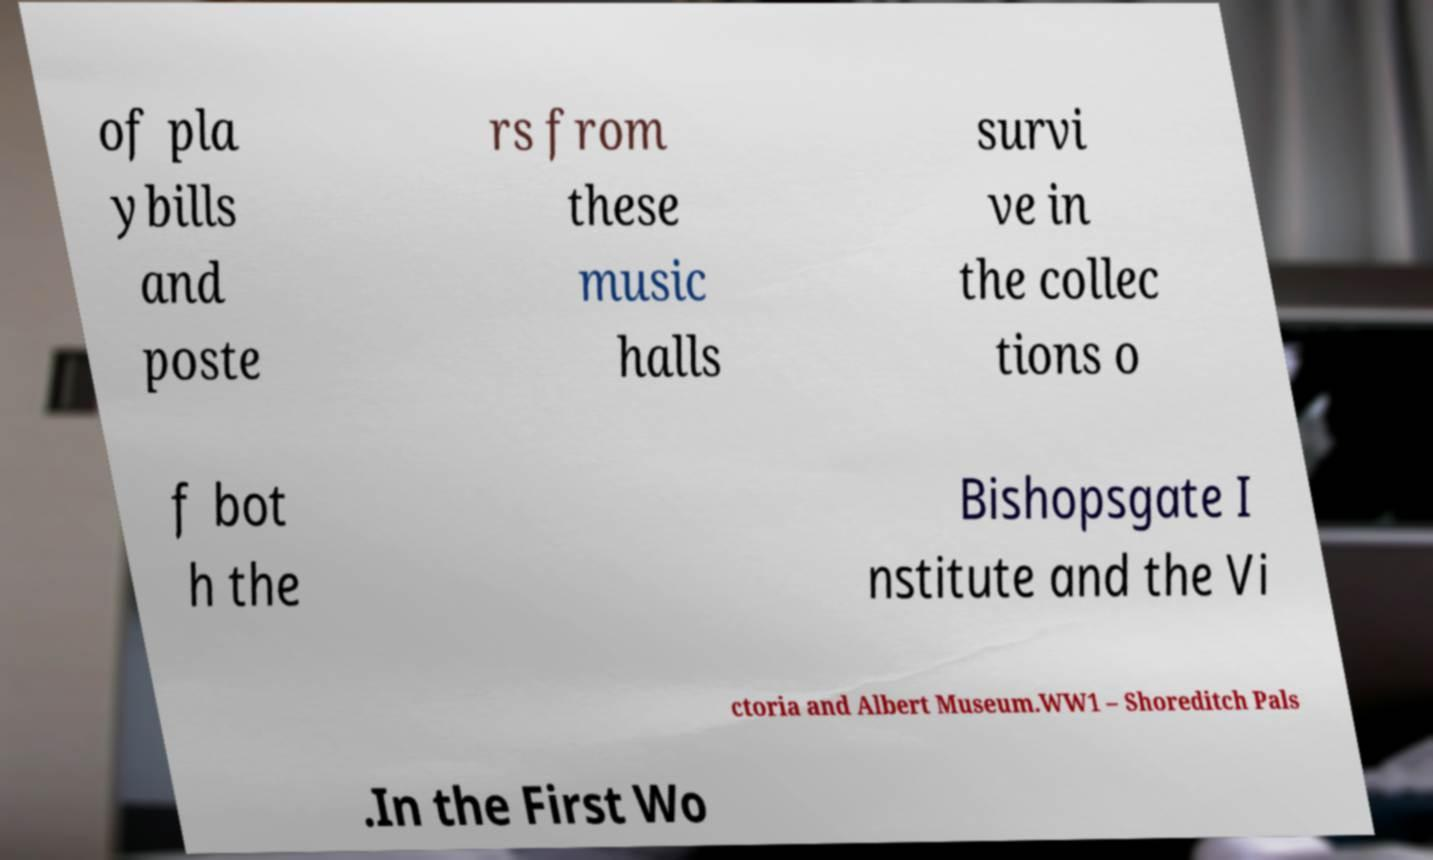Could you assist in decoding the text presented in this image and type it out clearly? of pla ybills and poste rs from these music halls survi ve in the collec tions o f bot h the Bishopsgate I nstitute and the Vi ctoria and Albert Museum.WW1 – Shoreditch Pals .In the First Wo 